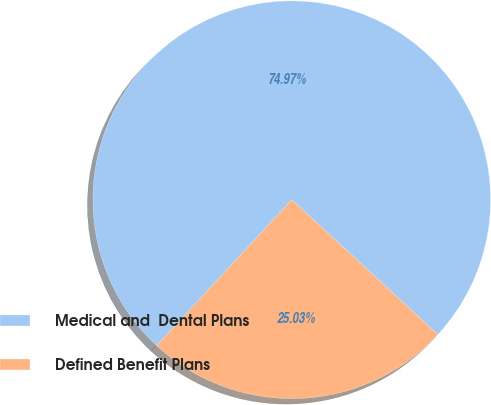<chart> <loc_0><loc_0><loc_500><loc_500><pie_chart><fcel>Medical and  Dental Plans<fcel>Defined Benefit Plans<nl><fcel>74.97%<fcel>25.03%<nl></chart> 